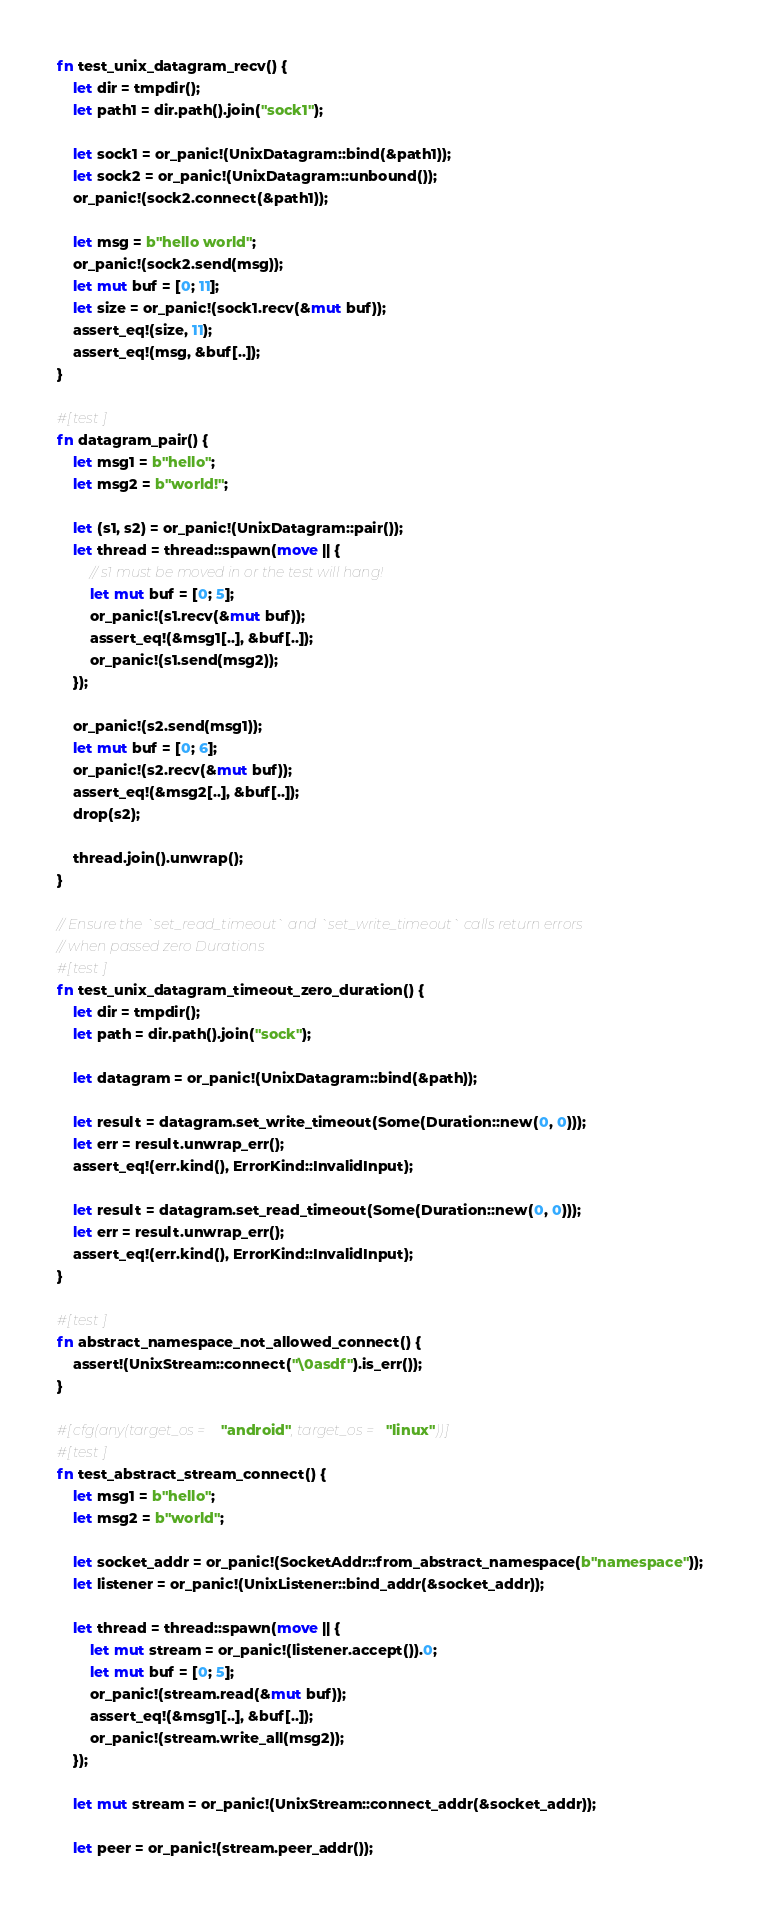<code> <loc_0><loc_0><loc_500><loc_500><_Rust_>fn test_unix_datagram_recv() {
    let dir = tmpdir();
    let path1 = dir.path().join("sock1");

    let sock1 = or_panic!(UnixDatagram::bind(&path1));
    let sock2 = or_panic!(UnixDatagram::unbound());
    or_panic!(sock2.connect(&path1));

    let msg = b"hello world";
    or_panic!(sock2.send(msg));
    let mut buf = [0; 11];
    let size = or_panic!(sock1.recv(&mut buf));
    assert_eq!(size, 11);
    assert_eq!(msg, &buf[..]);
}

#[test]
fn datagram_pair() {
    let msg1 = b"hello";
    let msg2 = b"world!";

    let (s1, s2) = or_panic!(UnixDatagram::pair());
    let thread = thread::spawn(move || {
        // s1 must be moved in or the test will hang!
        let mut buf = [0; 5];
        or_panic!(s1.recv(&mut buf));
        assert_eq!(&msg1[..], &buf[..]);
        or_panic!(s1.send(msg2));
    });

    or_panic!(s2.send(msg1));
    let mut buf = [0; 6];
    or_panic!(s2.recv(&mut buf));
    assert_eq!(&msg2[..], &buf[..]);
    drop(s2);

    thread.join().unwrap();
}

// Ensure the `set_read_timeout` and `set_write_timeout` calls return errors
// when passed zero Durations
#[test]
fn test_unix_datagram_timeout_zero_duration() {
    let dir = tmpdir();
    let path = dir.path().join("sock");

    let datagram = or_panic!(UnixDatagram::bind(&path));

    let result = datagram.set_write_timeout(Some(Duration::new(0, 0)));
    let err = result.unwrap_err();
    assert_eq!(err.kind(), ErrorKind::InvalidInput);

    let result = datagram.set_read_timeout(Some(Duration::new(0, 0)));
    let err = result.unwrap_err();
    assert_eq!(err.kind(), ErrorKind::InvalidInput);
}

#[test]
fn abstract_namespace_not_allowed_connect() {
    assert!(UnixStream::connect("\0asdf").is_err());
}

#[cfg(any(target_os = "android", target_os = "linux"))]
#[test]
fn test_abstract_stream_connect() {
    let msg1 = b"hello";
    let msg2 = b"world";

    let socket_addr = or_panic!(SocketAddr::from_abstract_namespace(b"namespace"));
    let listener = or_panic!(UnixListener::bind_addr(&socket_addr));

    let thread = thread::spawn(move || {
        let mut stream = or_panic!(listener.accept()).0;
        let mut buf = [0; 5];
        or_panic!(stream.read(&mut buf));
        assert_eq!(&msg1[..], &buf[..]);
        or_panic!(stream.write_all(msg2));
    });

    let mut stream = or_panic!(UnixStream::connect_addr(&socket_addr));

    let peer = or_panic!(stream.peer_addr());</code> 